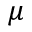<formula> <loc_0><loc_0><loc_500><loc_500>\mu</formula> 